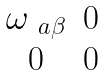<formula> <loc_0><loc_0><loc_500><loc_500>\begin{matrix} \omega _ { \ a \beta } & 0 \\ 0 & 0 \end{matrix}</formula> 